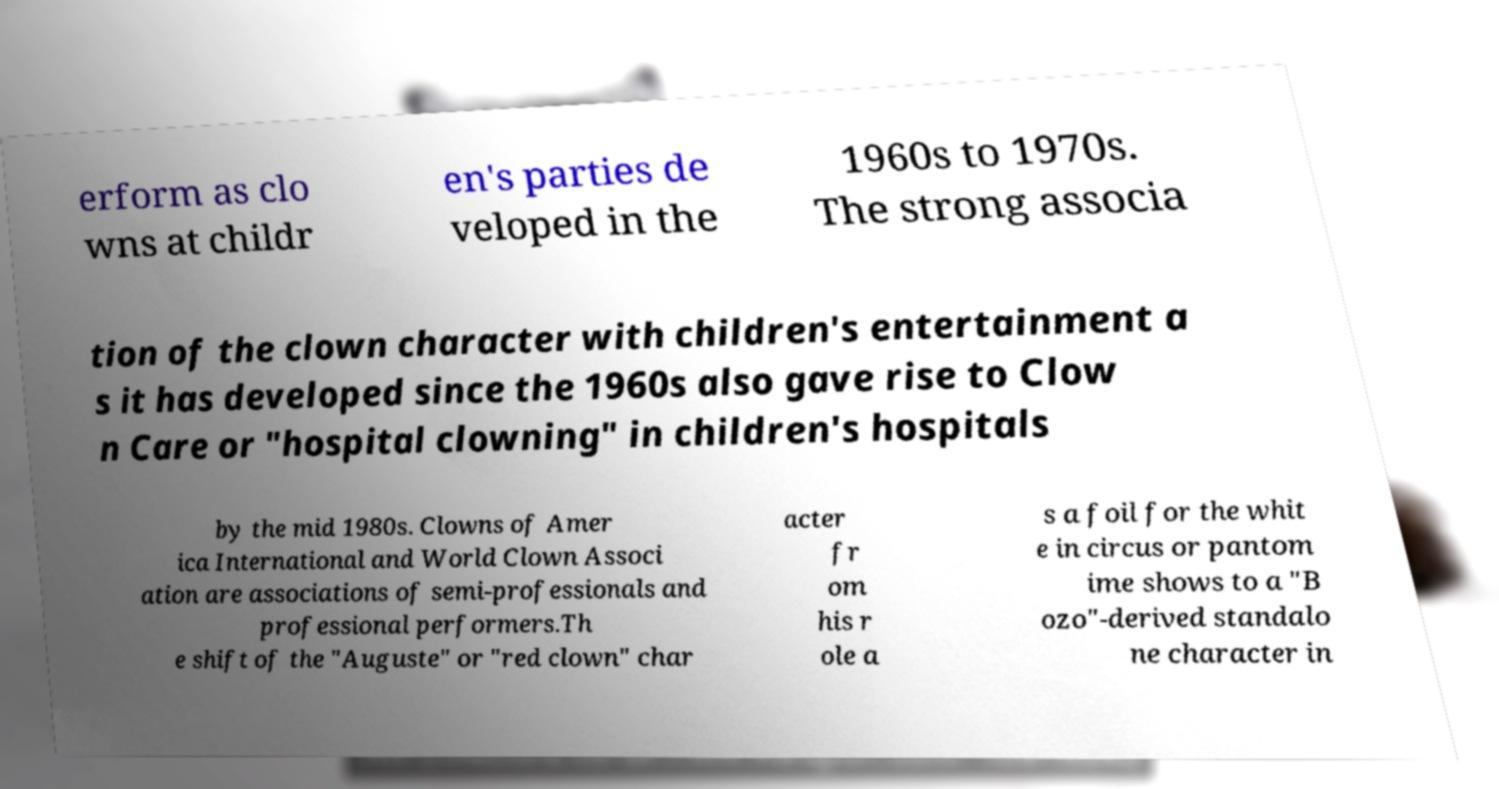Could you assist in decoding the text presented in this image and type it out clearly? erform as clo wns at childr en's parties de veloped in the 1960s to 1970s. The strong associa tion of the clown character with children's entertainment a s it has developed since the 1960s also gave rise to Clow n Care or "hospital clowning" in children's hospitals by the mid 1980s. Clowns of Amer ica International and World Clown Associ ation are associations of semi-professionals and professional performers.Th e shift of the "Auguste" or "red clown" char acter fr om his r ole a s a foil for the whit e in circus or pantom ime shows to a "B ozo"-derived standalo ne character in 